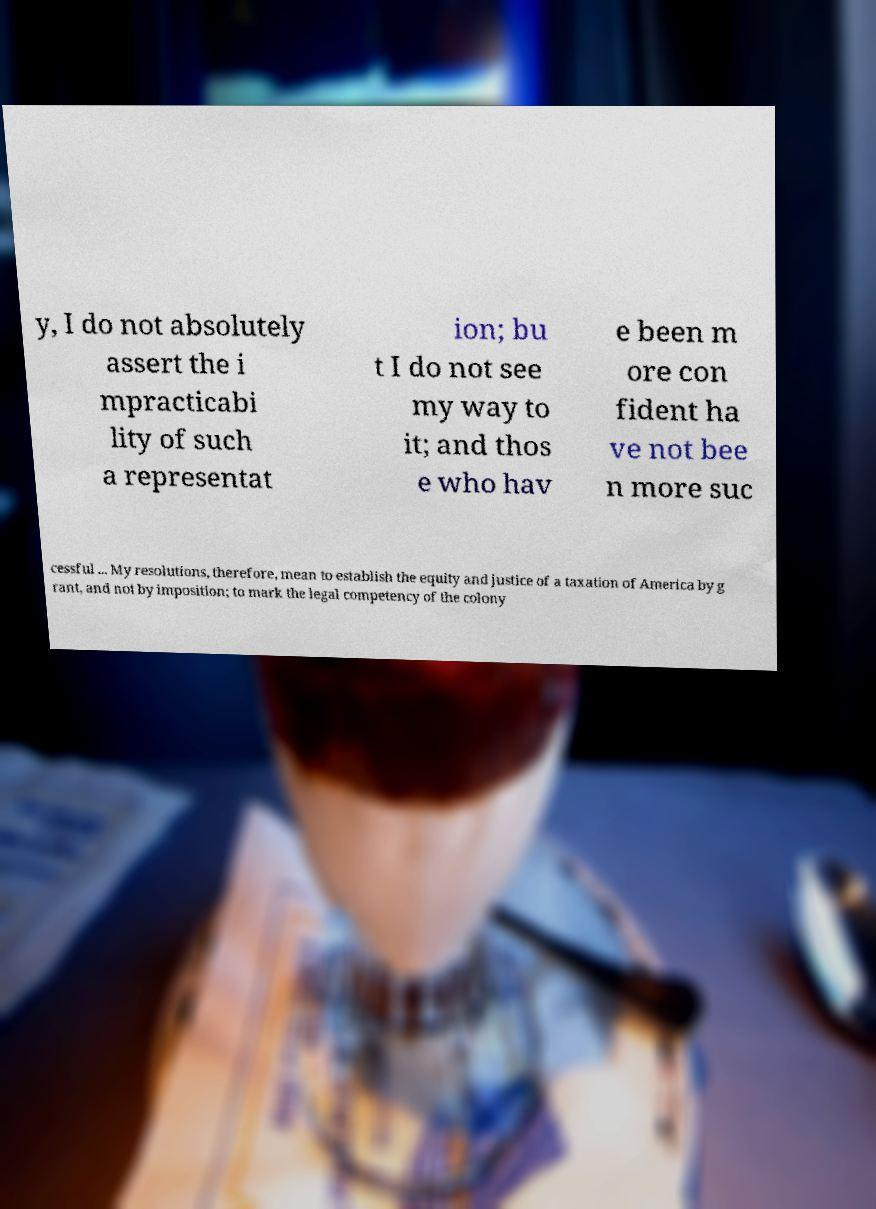Can you read and provide the text displayed in the image?This photo seems to have some interesting text. Can you extract and type it out for me? y, I do not absolutely assert the i mpracticabi lity of such a representat ion; bu t I do not see my way to it; and thos e who hav e been m ore con fident ha ve not bee n more suc cessful ... My resolutions, therefore, mean to establish the equity and justice of a taxation of America by g rant, and not by imposition; to mark the legal competency of the colony 